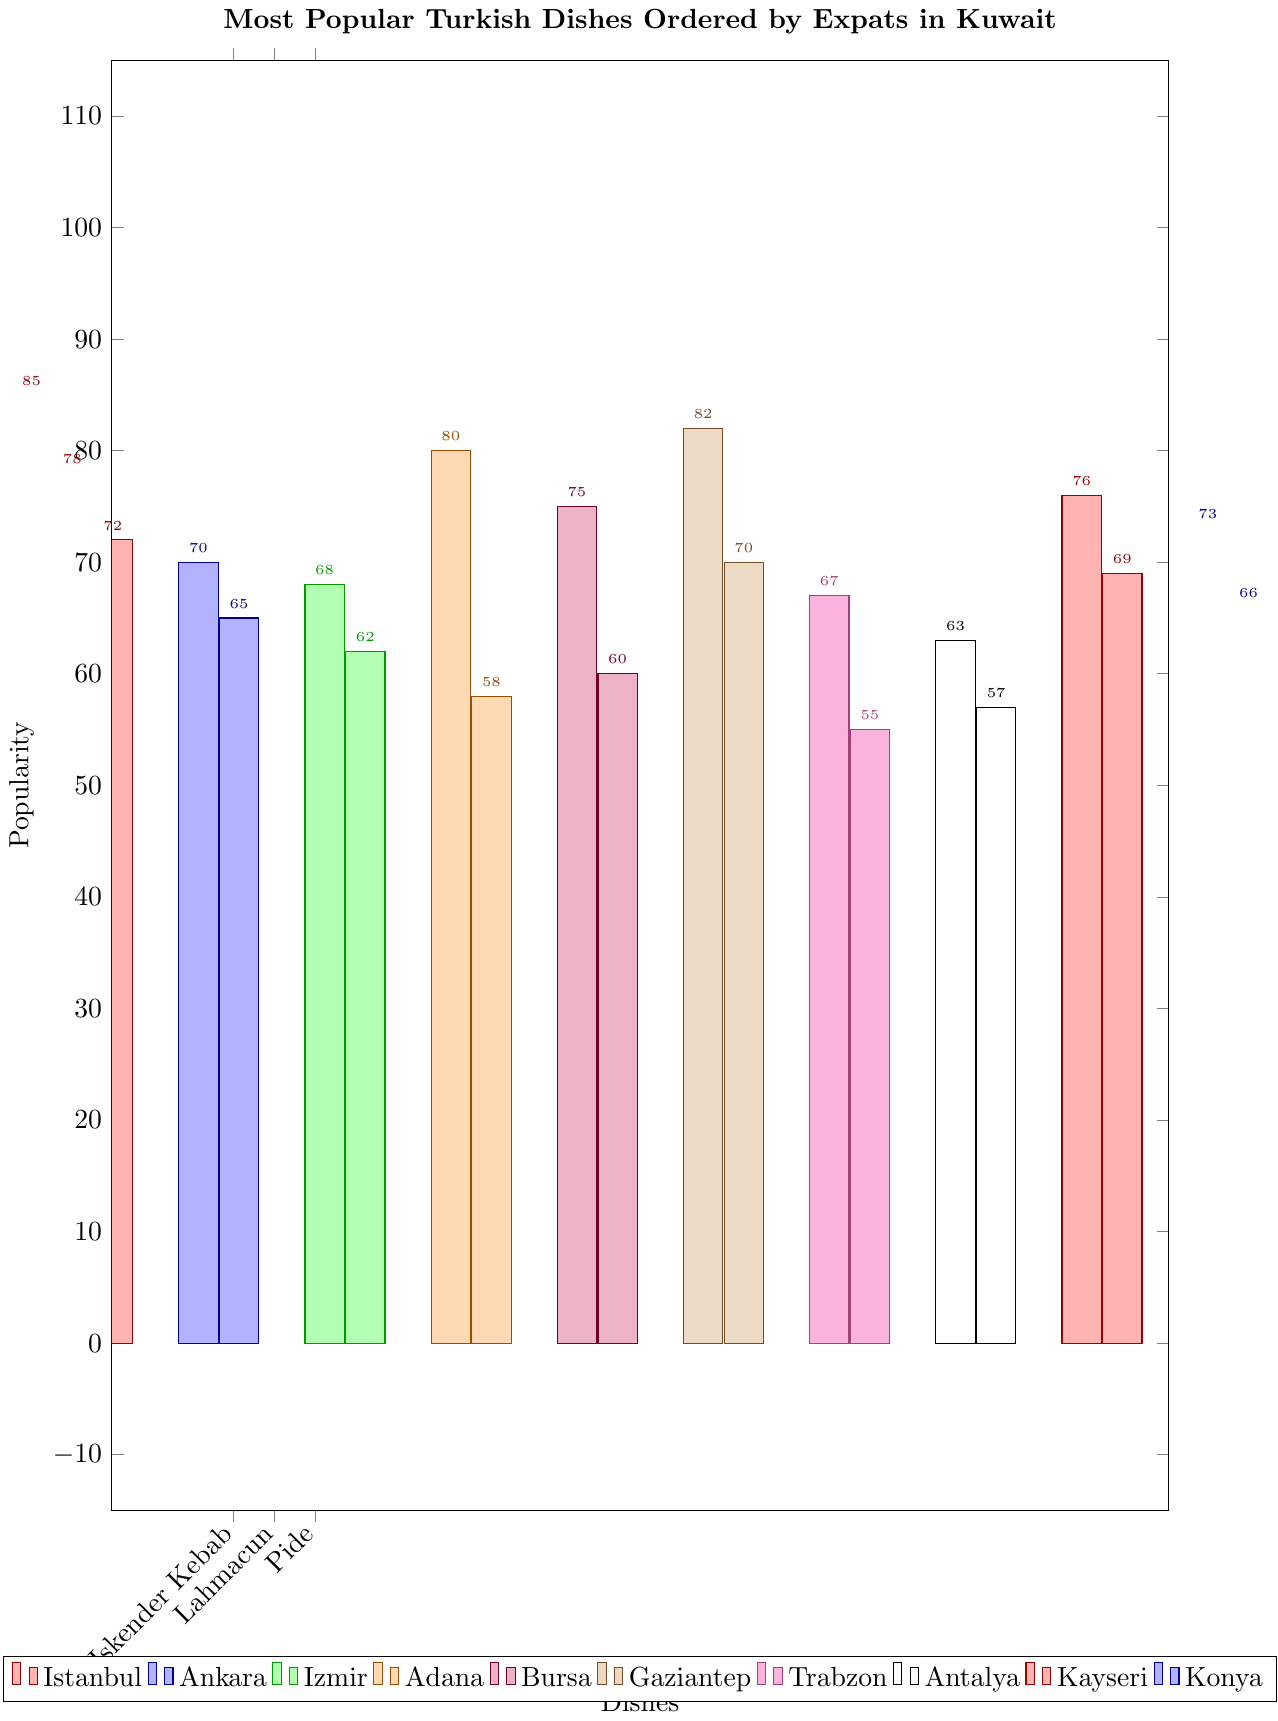Which dish from Istanbul is the most popular among expats in Kuwait? By looking at the figure, identify the tallest bar among the dishes from Istanbul. The dishes from Istanbul include Iskender Kebab, Lahmacun, and Pide. The tallest bar corresponds to the Iskender Kebab.
Answer: Iskender Kebab How does the popularity of Adana Kebab compare to that of Baklava? Find the height of the bars corresponding to Adana Kebab and Baklava. The bar height for Adana Kebab is 80, while Baklava is 82. Therefore, Baklava is slightly more popular.
Answer: Baklava is more popular What is the average popularity of the dishes from Bursa? Identify the bars related to Bursa, which are Inegol Kofte (75) and Cantik (60). Calculate their average: (75 + 60) / 2 = 135 / 2 = 67.5
Answer: 67.5 Which region has the dish with the lowest popularity? Look for the shortest bar across all regions, which corresponds to Kuymak from Trabzon with a popularity of 55.
Answer: Trabzon How many dishes have a popularity greater than 70? Count the number of bars with a height greater than 70. These dishes are Iskender Kebab, Lahmacun, Pide, Adana Kebab, Inegol Kofte, Baklava, Ali Nazik, Manti, and Etli Ekmek, which totals 9.
Answer: 9 dishes 